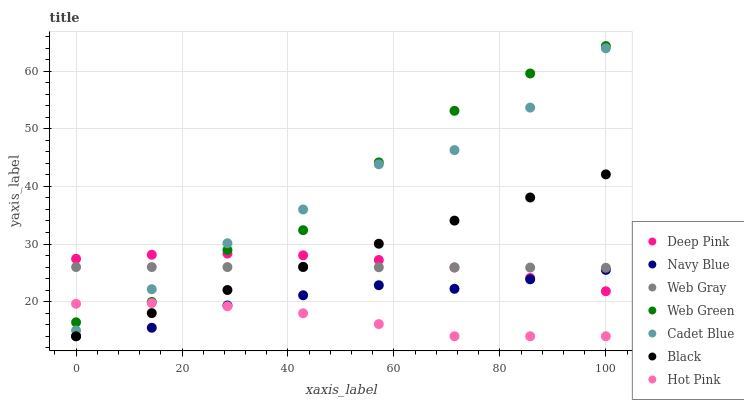Does Hot Pink have the minimum area under the curve?
Answer yes or no. Yes. Does Web Green have the maximum area under the curve?
Answer yes or no. Yes. Does Navy Blue have the minimum area under the curve?
Answer yes or no. No. Does Navy Blue have the maximum area under the curve?
Answer yes or no. No. Is Black the smoothest?
Answer yes or no. Yes. Is Web Green the roughest?
Answer yes or no. Yes. Is Navy Blue the smoothest?
Answer yes or no. No. Is Navy Blue the roughest?
Answer yes or no. No. Does Navy Blue have the lowest value?
Answer yes or no. Yes. Does Web Green have the lowest value?
Answer yes or no. No. Does Web Green have the highest value?
Answer yes or no. Yes. Does Navy Blue have the highest value?
Answer yes or no. No. Is Black less than Cadet Blue?
Answer yes or no. Yes. Is Web Gray greater than Hot Pink?
Answer yes or no. Yes. Does Navy Blue intersect Black?
Answer yes or no. Yes. Is Navy Blue less than Black?
Answer yes or no. No. Is Navy Blue greater than Black?
Answer yes or no. No. Does Black intersect Cadet Blue?
Answer yes or no. No. 